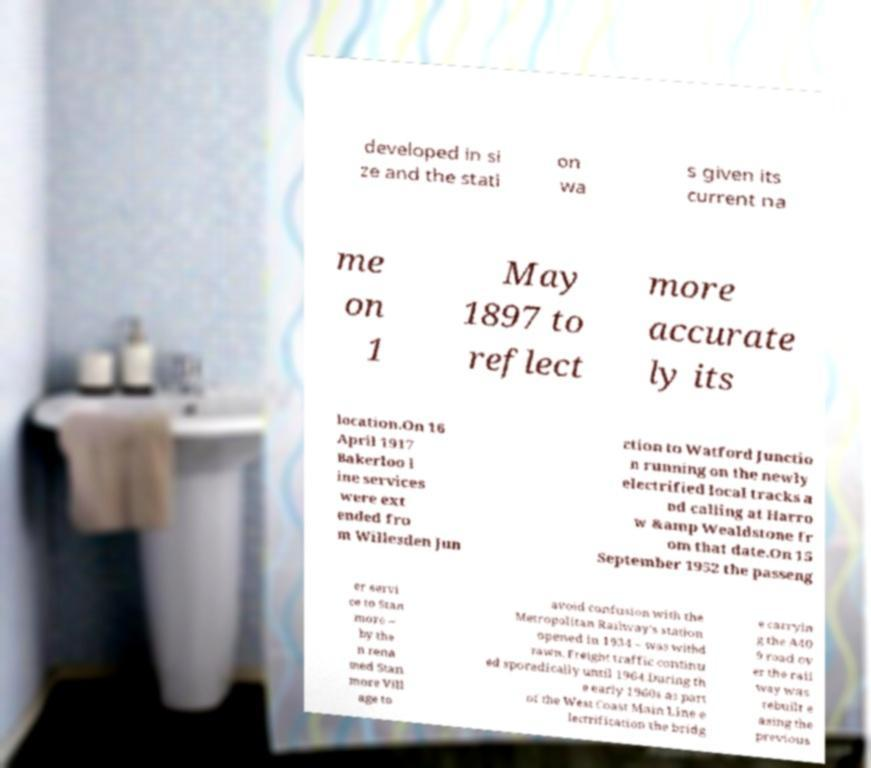What messages or text are displayed in this image? I need them in a readable, typed format. developed in si ze and the stati on wa s given its current na me on 1 May 1897 to reflect more accurate ly its location.On 16 April 1917 Bakerloo l ine services were ext ended fro m Willesden Jun ction to Watford Junctio n running on the newly electrified local tracks a nd calling at Harro w &amp Wealdstone fr om that date.On 15 September 1952 the passeng er servi ce to Stan more – by the n rena med Stan more Vill age to avoid confusion with the Metropolitan Railway's station opened in 1934 – was withd rawn. Freight traffic continu ed sporadically until 1964.During th e early 1960s as part of the West Coast Main Line e lectrification the bridg e carryin g the A40 9 road ov er the rail way was rebuilt e asing the previous 